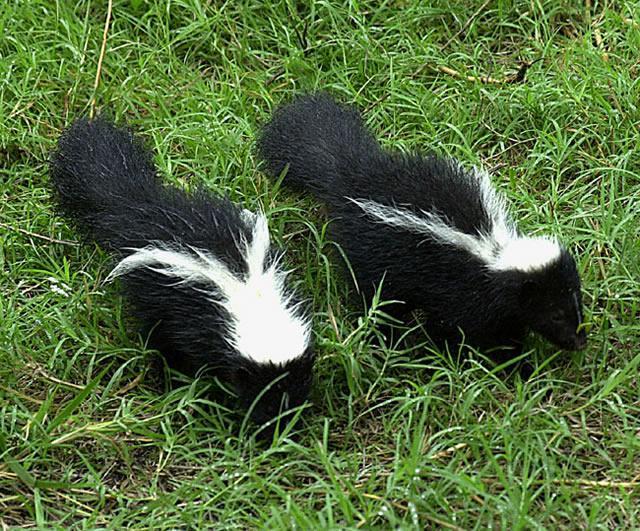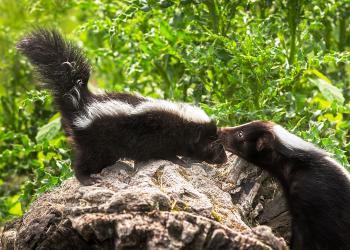The first image is the image on the left, the second image is the image on the right. Assess this claim about the two images: "One image contains a single skunk on all fours, and the other image features two side-by-side skunks with look-alike coloring and walking poses.". Correct or not? Answer yes or no. No. The first image is the image on the left, the second image is the image on the right. Considering the images on both sides, is "There are three skunks." valid? Answer yes or no. No. 